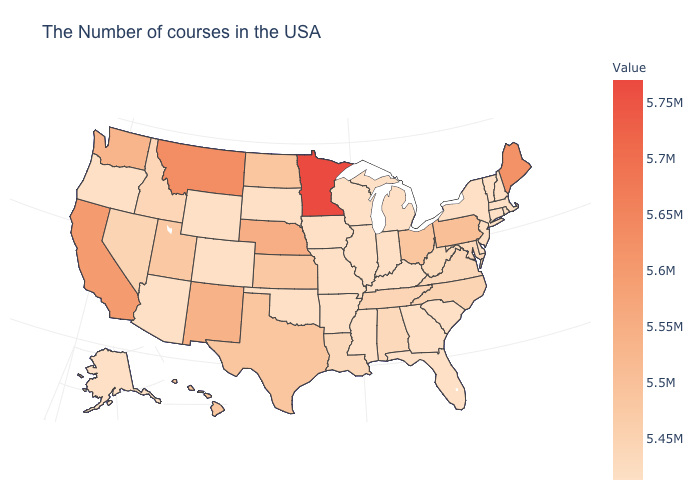Is the legend a continuous bar?
Answer briefly. Yes. Among the states that border Colorado , which have the highest value?
Give a very brief answer. Nebraska. Among the states that border Utah , does Arizona have the highest value?
Short answer required. No. Among the states that border New York , which have the lowest value?
Answer briefly. Massachusetts, Vermont, Connecticut. Among the states that border Utah , does Colorado have the lowest value?
Write a very short answer. Yes. 